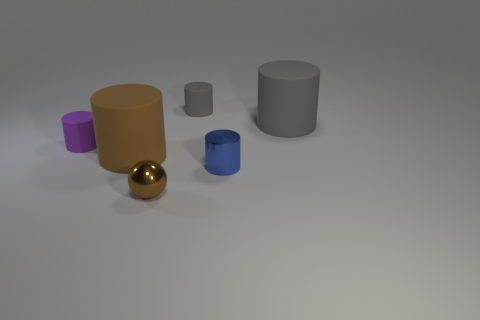Can you describe the shapes and colors of the objects presented in the image? Certainly! The image features a collection of geometric solid objects. Starting from the left, there's a small purple cylinder, followed by a larger brown cylinder. In front of these, there is a shiny golden sphere. To the right, there is a small blue cylinder and a larger gray cylinder alongside each other.  How is the lighting in this image? The lighting in the image appears to be soft and diffused, coming from above. There are subtle shadows under each object, indicating the light source isn't directly overhead but slightly angled. Overall, the lighting contributes to the soft matte appearance of most objects, except the golden sphere which reflects light and looks shiny. 